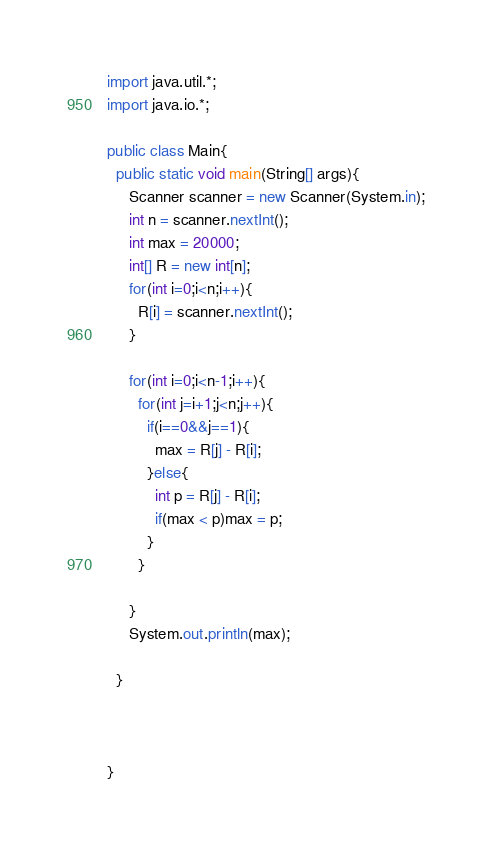Convert code to text. <code><loc_0><loc_0><loc_500><loc_500><_Java_>import java.util.*;
import java.io.*;

public class Main{
  public static void main(String[] args){
     Scanner scanner = new Scanner(System.in);
     int n = scanner.nextInt();
     int max = 20000;
     int[] R = new int[n];
     for(int i=0;i<n;i++){
       R[i] = scanner.nextInt();
     }

     for(int i=0;i<n-1;i++){
       for(int j=i+1;j<n;j++){
         if(i==0&&j==1){
           max = R[j] - R[i];
         }else{
           int p = R[j] - R[i];
           if(max < p)max = p;
         }
       }

     }
     System.out.println(max);

  }



}
</code> 